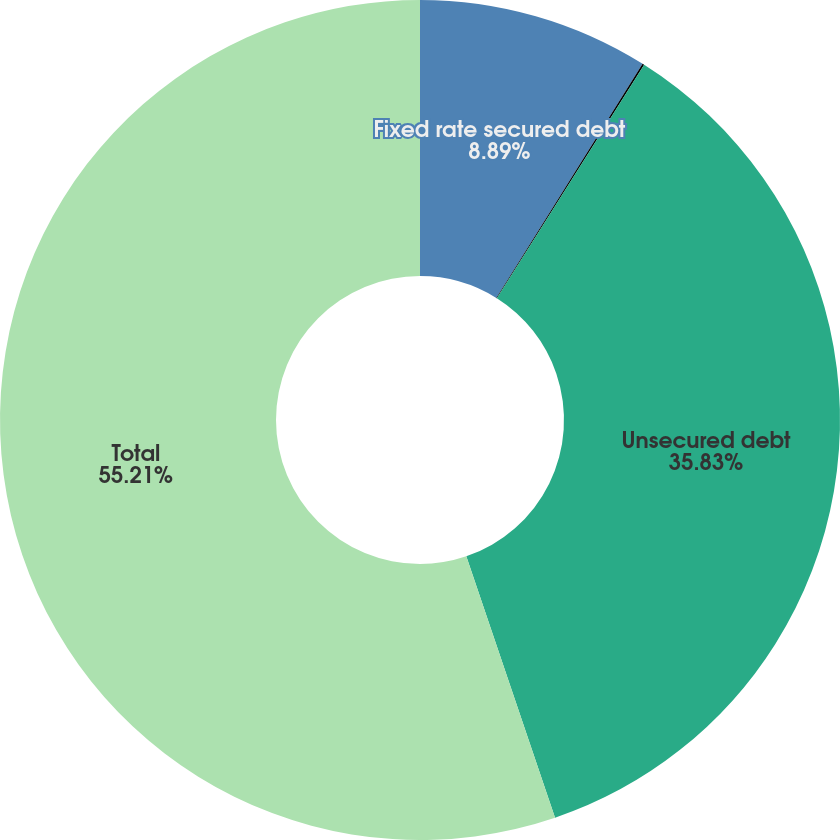<chart> <loc_0><loc_0><loc_500><loc_500><pie_chart><fcel>Fixed rate secured debt<fcel>Variable rate secured debt<fcel>Unsecured debt<fcel>Total<nl><fcel>8.89%<fcel>0.07%<fcel>35.83%<fcel>55.21%<nl></chart> 